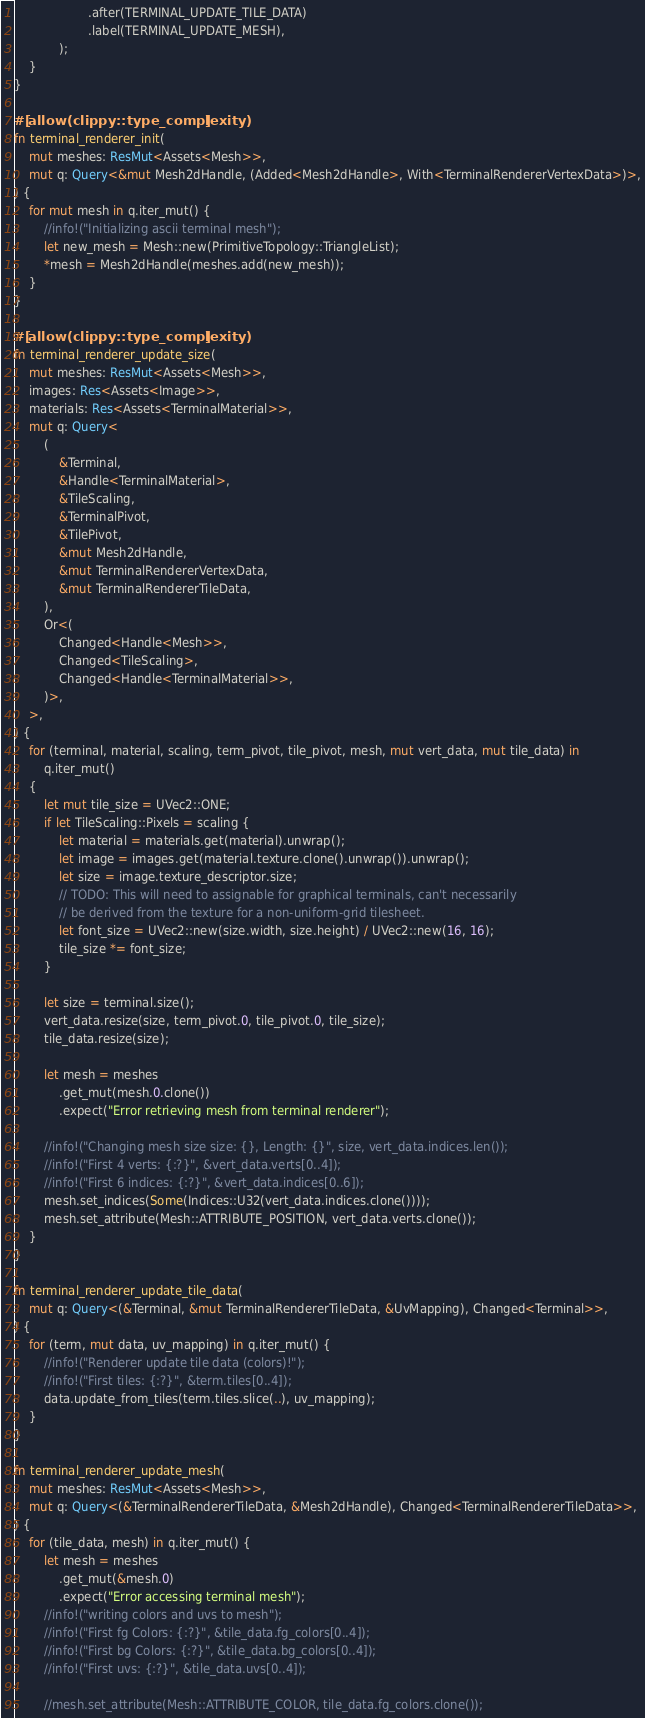Convert code to text. <code><loc_0><loc_0><loc_500><loc_500><_Rust_>                    .after(TERMINAL_UPDATE_TILE_DATA)
                    .label(TERMINAL_UPDATE_MESH),
            );
    }
}

#[allow(clippy::type_complexity)]
fn terminal_renderer_init(
    mut meshes: ResMut<Assets<Mesh>>,
    mut q: Query<&mut Mesh2dHandle, (Added<Mesh2dHandle>, With<TerminalRendererVertexData>)>,
) {
    for mut mesh in q.iter_mut() {
        //info!("Initializing ascii terminal mesh");
        let new_mesh = Mesh::new(PrimitiveTopology::TriangleList);
        *mesh = Mesh2dHandle(meshes.add(new_mesh));
    }
}

#[allow(clippy::type_complexity)]
fn terminal_renderer_update_size(
    mut meshes: ResMut<Assets<Mesh>>,
    images: Res<Assets<Image>>,
    materials: Res<Assets<TerminalMaterial>>,
    mut q: Query<
        (
            &Terminal,
            &Handle<TerminalMaterial>,
            &TileScaling,
            &TerminalPivot,
            &TilePivot,
            &mut Mesh2dHandle,
            &mut TerminalRendererVertexData,
            &mut TerminalRendererTileData,
        ),
        Or<(
            Changed<Handle<Mesh>>,
            Changed<TileScaling>,
            Changed<Handle<TerminalMaterial>>,
        )>,
    >,
) {
    for (terminal, material, scaling, term_pivot, tile_pivot, mesh, mut vert_data, mut tile_data) in
        q.iter_mut()
    {
        let mut tile_size = UVec2::ONE;
        if let TileScaling::Pixels = scaling {
            let material = materials.get(material).unwrap();
            let image = images.get(material.texture.clone().unwrap()).unwrap();
            let size = image.texture_descriptor.size;
            // TODO: This will need to assignable for graphical terminals, can't necessarily
            // be derived from the texture for a non-uniform-grid tilesheet.
            let font_size = UVec2::new(size.width, size.height) / UVec2::new(16, 16);
            tile_size *= font_size;
        }

        let size = terminal.size();
        vert_data.resize(size, term_pivot.0, tile_pivot.0, tile_size);
        tile_data.resize(size);

        let mesh = meshes
            .get_mut(mesh.0.clone())
            .expect("Error retrieving mesh from terminal renderer");

        //info!("Changing mesh size size: {}, Length: {}", size, vert_data.indices.len());
        //info!("First 4 verts: {:?}", &vert_data.verts[0..4]);
        //info!("First 6 indices: {:?}", &vert_data.indices[0..6]);
        mesh.set_indices(Some(Indices::U32(vert_data.indices.clone())));
        mesh.set_attribute(Mesh::ATTRIBUTE_POSITION, vert_data.verts.clone());
    }
}

fn terminal_renderer_update_tile_data(
    mut q: Query<(&Terminal, &mut TerminalRendererTileData, &UvMapping), Changed<Terminal>>,
) {
    for (term, mut data, uv_mapping) in q.iter_mut() {
        //info!("Renderer update tile data (colors)!");
        //info!("First tiles: {:?}", &term.tiles[0..4]);
        data.update_from_tiles(term.tiles.slice(..), uv_mapping);
    }
}

fn terminal_renderer_update_mesh(
    mut meshes: ResMut<Assets<Mesh>>,
    mut q: Query<(&TerminalRendererTileData, &Mesh2dHandle), Changed<TerminalRendererTileData>>,
) {
    for (tile_data, mesh) in q.iter_mut() {
        let mesh = meshes
            .get_mut(&mesh.0)
            .expect("Error accessing terminal mesh");
        //info!("writing colors and uvs to mesh");
        //info!("First fg Colors: {:?}", &tile_data.fg_colors[0..4]);
        //info!("First bg Colors: {:?}", &tile_data.bg_colors[0..4]);
        //info!("First uvs: {:?}", &tile_data.uvs[0..4]);

        //mesh.set_attribute(Mesh::ATTRIBUTE_COLOR, tile_data.fg_colors.clone());
</code> 